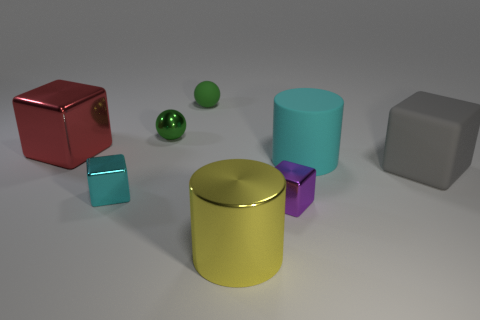What number of big red objects are made of the same material as the purple block? 1 